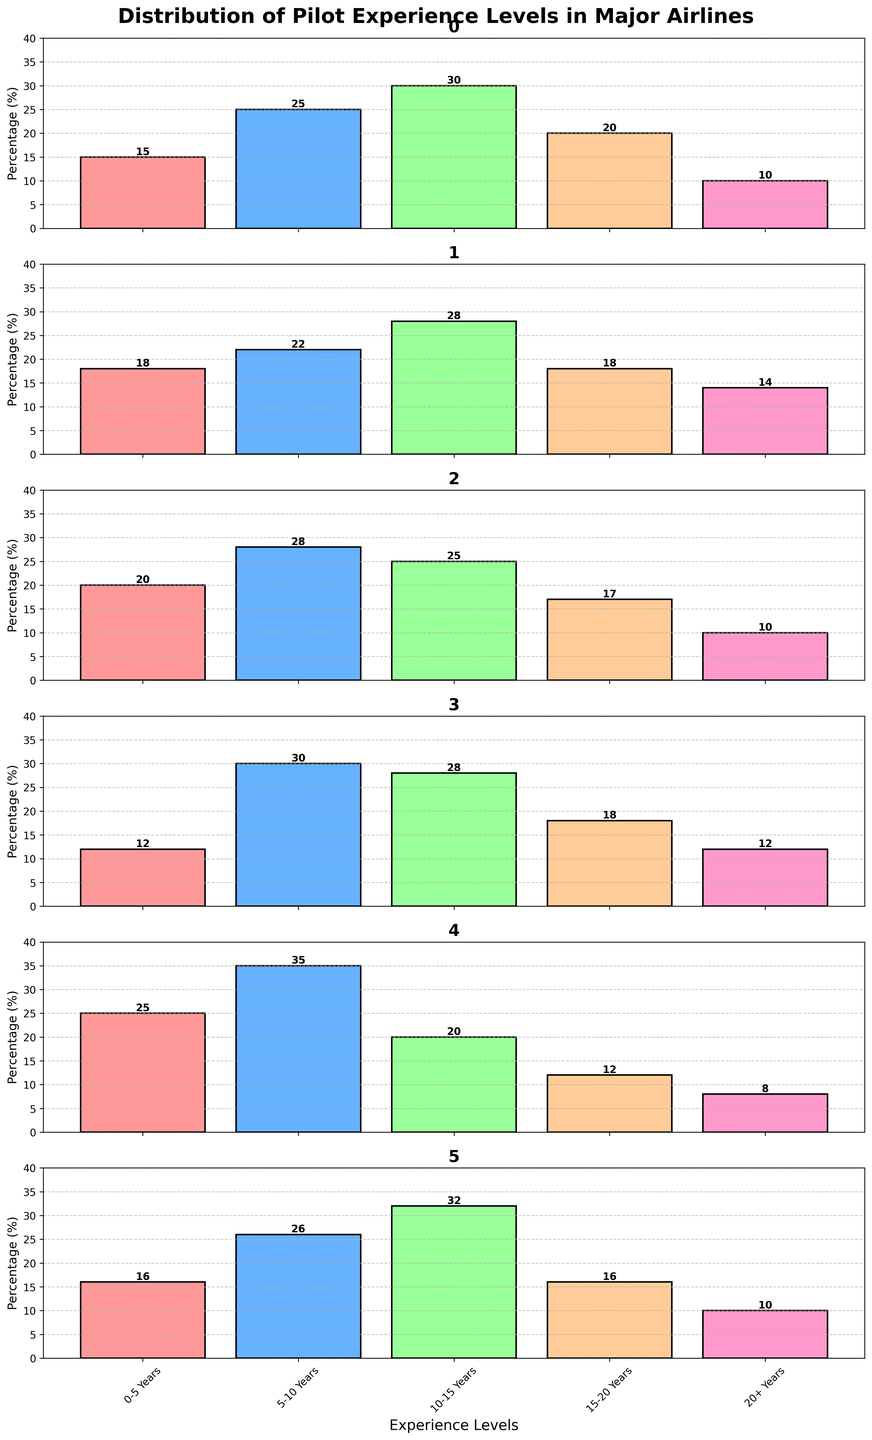Which airline has the highest percentage of pilots with 0-5 years of experience? Look at the bar representing 0-5 years for each airline and determine the highest value. JetBlue Airways has the highest bar at 25%.
Answer: JetBlue Airways What is the total percentage of Delta Air Lines pilots with 10-15 years and 15-20 years of experience? Add the percentages of Delta Air Lines pilots with 10-15 years (30%) and 15-20 years (20%) of experience. 30 + 20 = 50.
Answer: 50% Which airline has the lowest percentage of pilots with over 20+ years of experience? Compare the bars representing 20+ years across airlines and identify the shortest bar. JetBlue Airways has the lowest at 8%.
Answer: JetBlue Airways How many airlines have more pilots with 5-10 years of experience compared to any other experience level? Look at the bars for each airline and see where the 5-10 years bar is the tallest among all experience levels. Delta Air Lines (25%), Southwest Airlines (30%), and JetBlue Airways (35%).
Answer: Three What is the difference in the percentage of pilots with 0-5 years of experience between Alaska Airlines and American Airlines? Subtract the percentage for American Airlines (20%) from Alaska Airlines (16%). 20 - 16 = 4.
Answer: 4% Which experience level has the most consistent percentage across all six airlines? Look at the bars for each experience level across all six airlines and determine which one varies the least visually. Both 0-5 years and 20+ years show less variation compared to others, but 0-5 years has a closer range across airlines.
Answer: 0-5 Years Which airline has the most diverse spread of experience levels? Look at the overall distribution of bars across each airline and see where the differences between the highest and lowest percentages are the greatest. JetBlue Airways shows a wider spread with high variation between categories.
Answer: JetBlue Airways Are there any airlines where pilots with 10-15 years of experience form the largest group? Check the 10-15 years bar for each airline to see if it's taller compared to other experience levels for that airline. Alaska Airlines (32%) and Delta Air Lines (30%).
Answer: Two What is the combined percentage of pilots with at least 15 years of experience for Southwest Airlines? Sum the percentages of Southwest Airlines pilots with 15-20 years (18%) and 20+ years (12%). 18 + 12 = 30.
Answer: 30% 